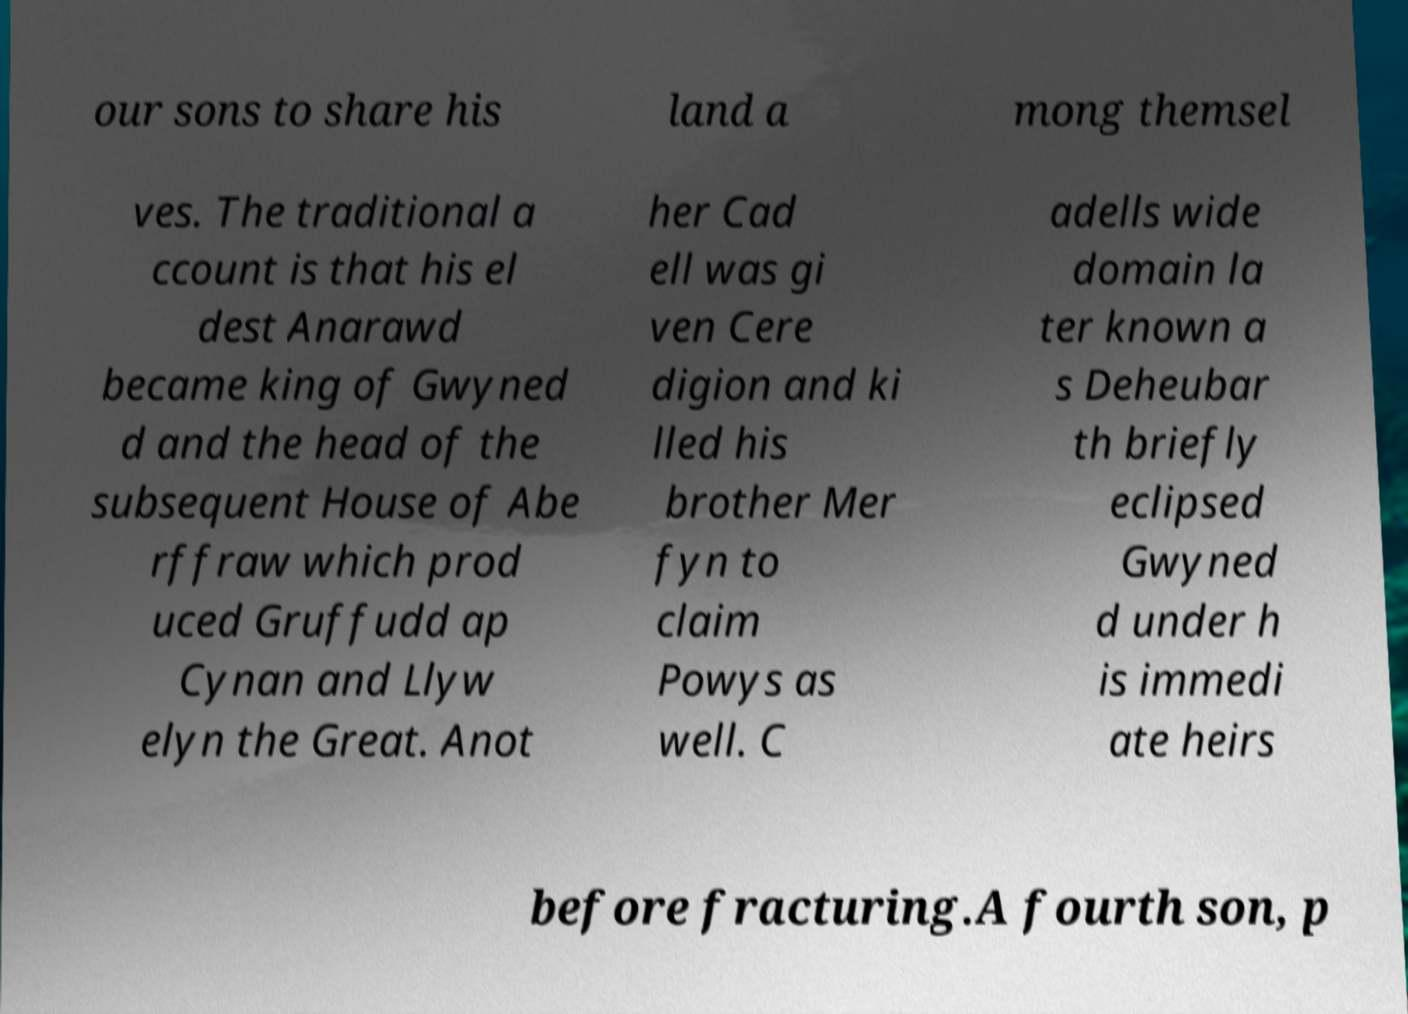Please identify and transcribe the text found in this image. our sons to share his land a mong themsel ves. The traditional a ccount is that his el dest Anarawd became king of Gwyned d and the head of the subsequent House of Abe rffraw which prod uced Gruffudd ap Cynan and Llyw elyn the Great. Anot her Cad ell was gi ven Cere digion and ki lled his brother Mer fyn to claim Powys as well. C adells wide domain la ter known a s Deheubar th briefly eclipsed Gwyned d under h is immedi ate heirs before fracturing.A fourth son, p 